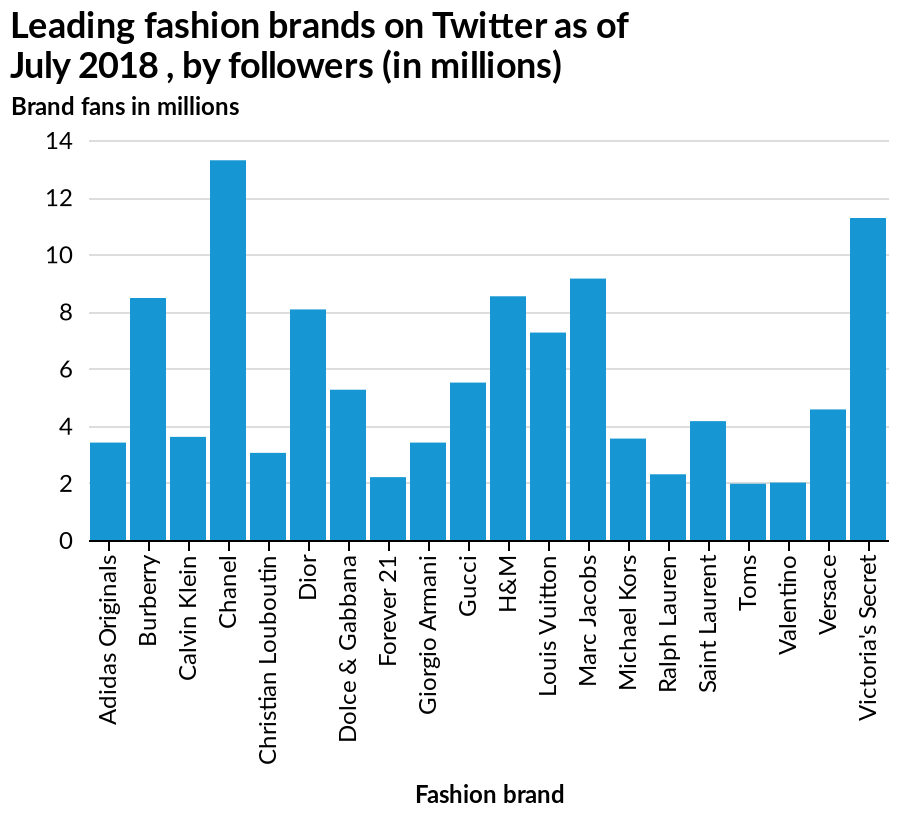<image>
How are the fashion brands represented on the x-axis of the bar plot?  The x-axis of the bar plot represents the different fashion brands. please summary the statistics and relations of the chart only 2 brands scored over 10, while nearly half 9/20 scored less than 4. One high street brand, H & M scored highly 9. Which brand mentioned in the figure has the smallest number of followers? Valentino has the smallest number of followers. What is the range of followers shown on the y-axis of the bar plot?  The y-axis of the bar plot displays the number of brand fans in millions. 